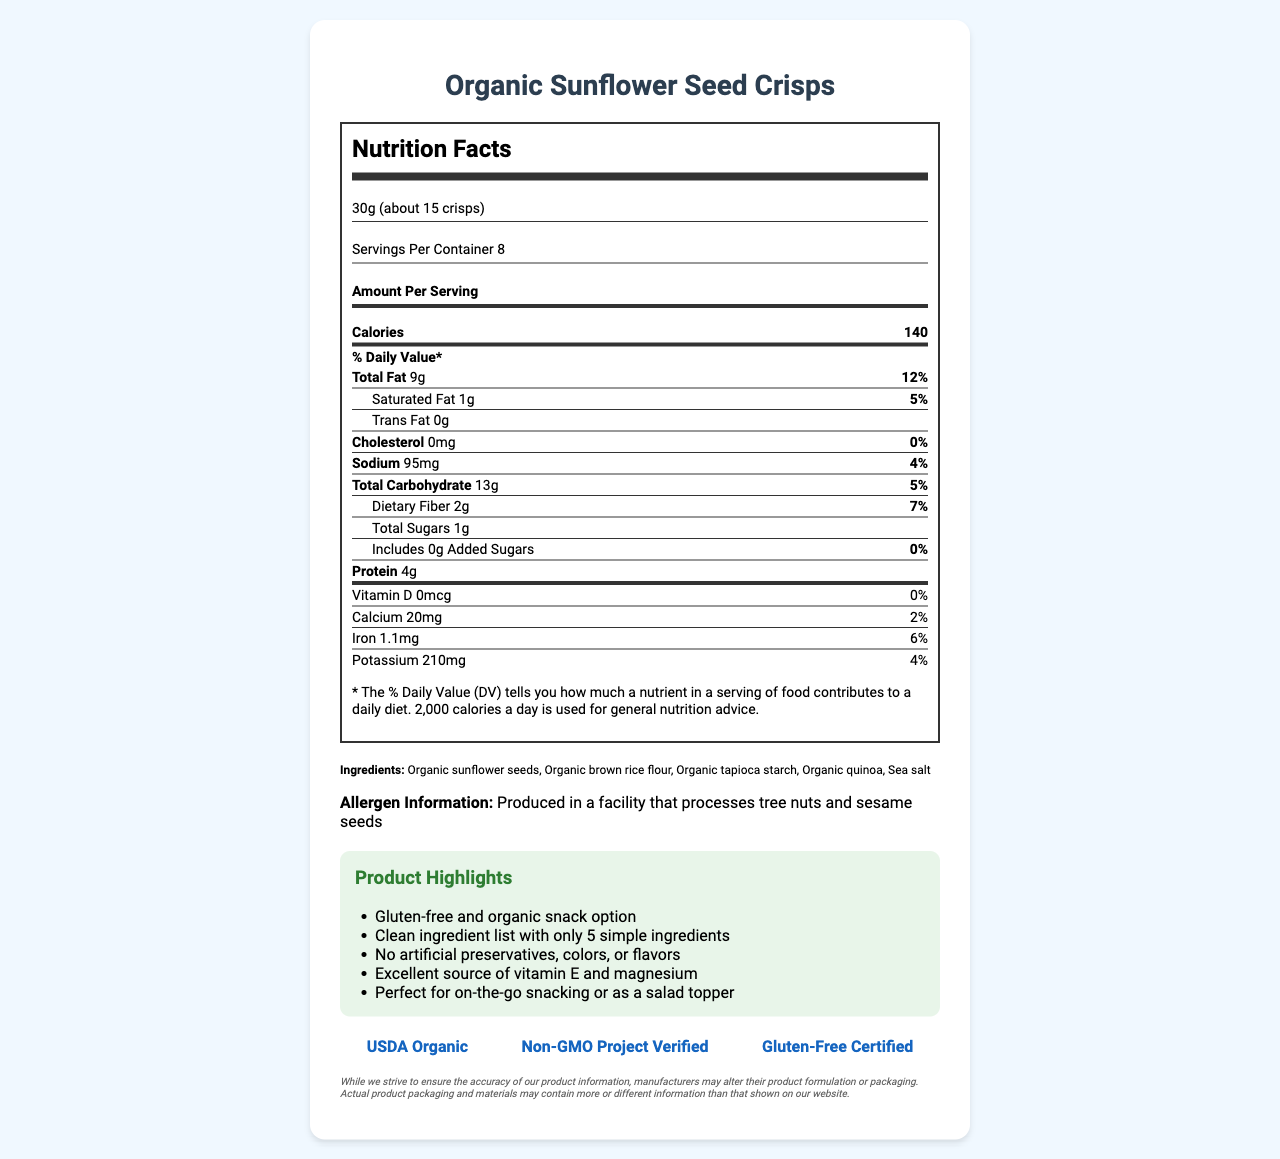what is the serving size of the Organic Sunflower Seed Crisps? The serving size is stated near the top of the nutrition label.
Answer: 30g (about 15 crisps) how many calories are in one serving? The number of calories per serving is clearly listed in the "Amount Per Serving" section.
Answer: 140 what is the daily value percentage for total fat? The daily value percentage for total fat is listed next to "Total Fat" on the nutrition label.
Answer: 12% are there any added sugars in this product? The label indicates that added sugars amount to 0g and therefore give a 0% daily value.
Answer: No how much protein is in one serving of these crisps? The amount of protein per serving is shown in the "Amount Per Serving" section.
Answer: 4g what ingredient is listed first? Ingredients are listed by quantity, with the largest first, and "Organic sunflower seeds" is the first.
Answer: Organic sunflower seeds which of the following certifications does the product have? A. USDA Organic B. Fair Trade C. Kosher D. Non-GMO Project Verified The certifications listed are USDA Organic, Non-GMO Project Verified, and Gluten-Free Certified.
Answer: A and D how much sodium is in one serving? The sodium content per serving is mentioned in the nutrition section.
Answer: 95mg is this product produced in a facility that processes peanuts? The allergen information states it is produced in a facility that processes tree nuts and sesame seeds, not peanuts.
Answer: No how many ingredients are in this product? The ingredients list contains five items: organic sunflower seeds, organic brown rice flour, organic tapioca starch, organic quinoa, and sea salt.
Answer: 5 how many servings are in the entire container? The servings per container are clearly mentioned.
Answer: 8 how much dietary fiber is in one serving? The dietary fiber content per serving is listed as 2g.
Answer: 2g does this product contain any artificial preservatives, colors, or flavors? According to the marketing points, the product has no artificial preservatives, colors, or flavors.
Answer: No which element is not represented in the nutrition facts? I. Vitamin C II. Vitamin D III. Potassium The label does not mention Vitamin C, while Vitamin D and Potassium are included.
Answer: I Is this product suitable for people with gluten sensitivities or celiac disease? The product is certified Gluten-Free.
Answer: Yes summarize the main marketing points of the product This summary encapsulates the key marketing highlights as listed in the document.
Answer: The Organic Sunflower Seed Crisps offers a gluten-free, organic snack option with a clean ingredient list of only five simple ingredients. It is free from artificial preservatives, colors, or flavors and serves as an excellent source of vitamin E and magnesium. It is suitable for on-the-go snacking or as a salad topper. how much vitamin E does this product contain? The document does not mention the content or daily value percentage of vitamin E.
Answer: Not enough information 